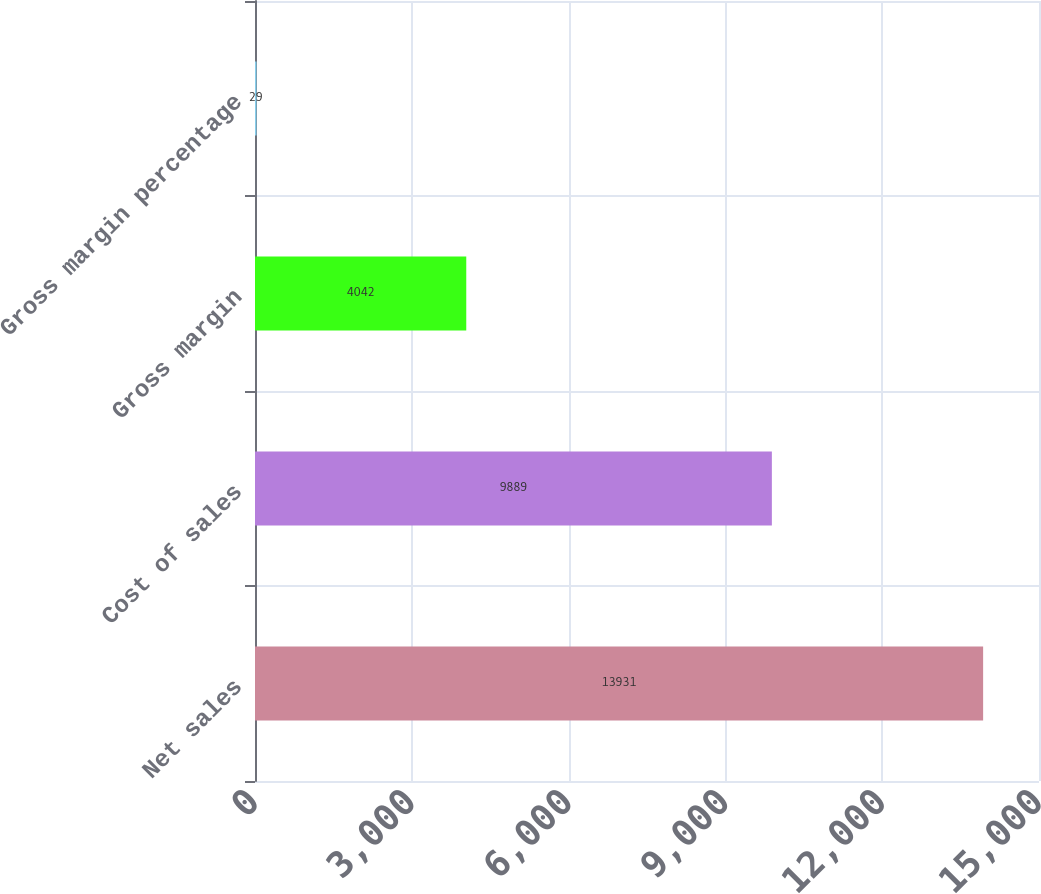Convert chart. <chart><loc_0><loc_0><loc_500><loc_500><bar_chart><fcel>Net sales<fcel>Cost of sales<fcel>Gross margin<fcel>Gross margin percentage<nl><fcel>13931<fcel>9889<fcel>4042<fcel>29<nl></chart> 